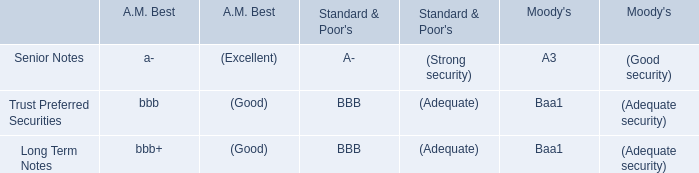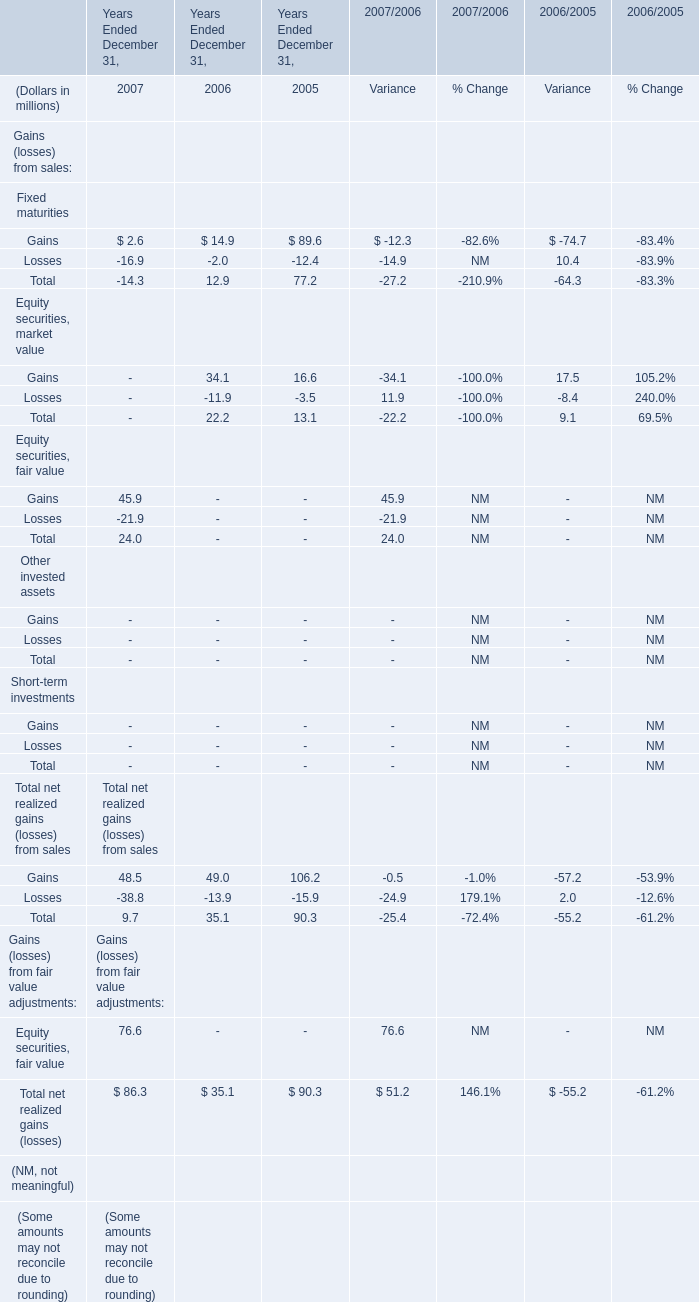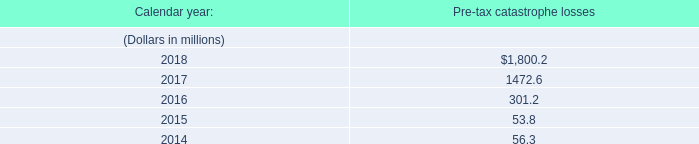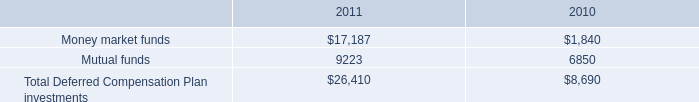What's the 40 % of total elements in 2006? (in million) 
Computations: (35.1 * 0.4)
Answer: 14.04. 